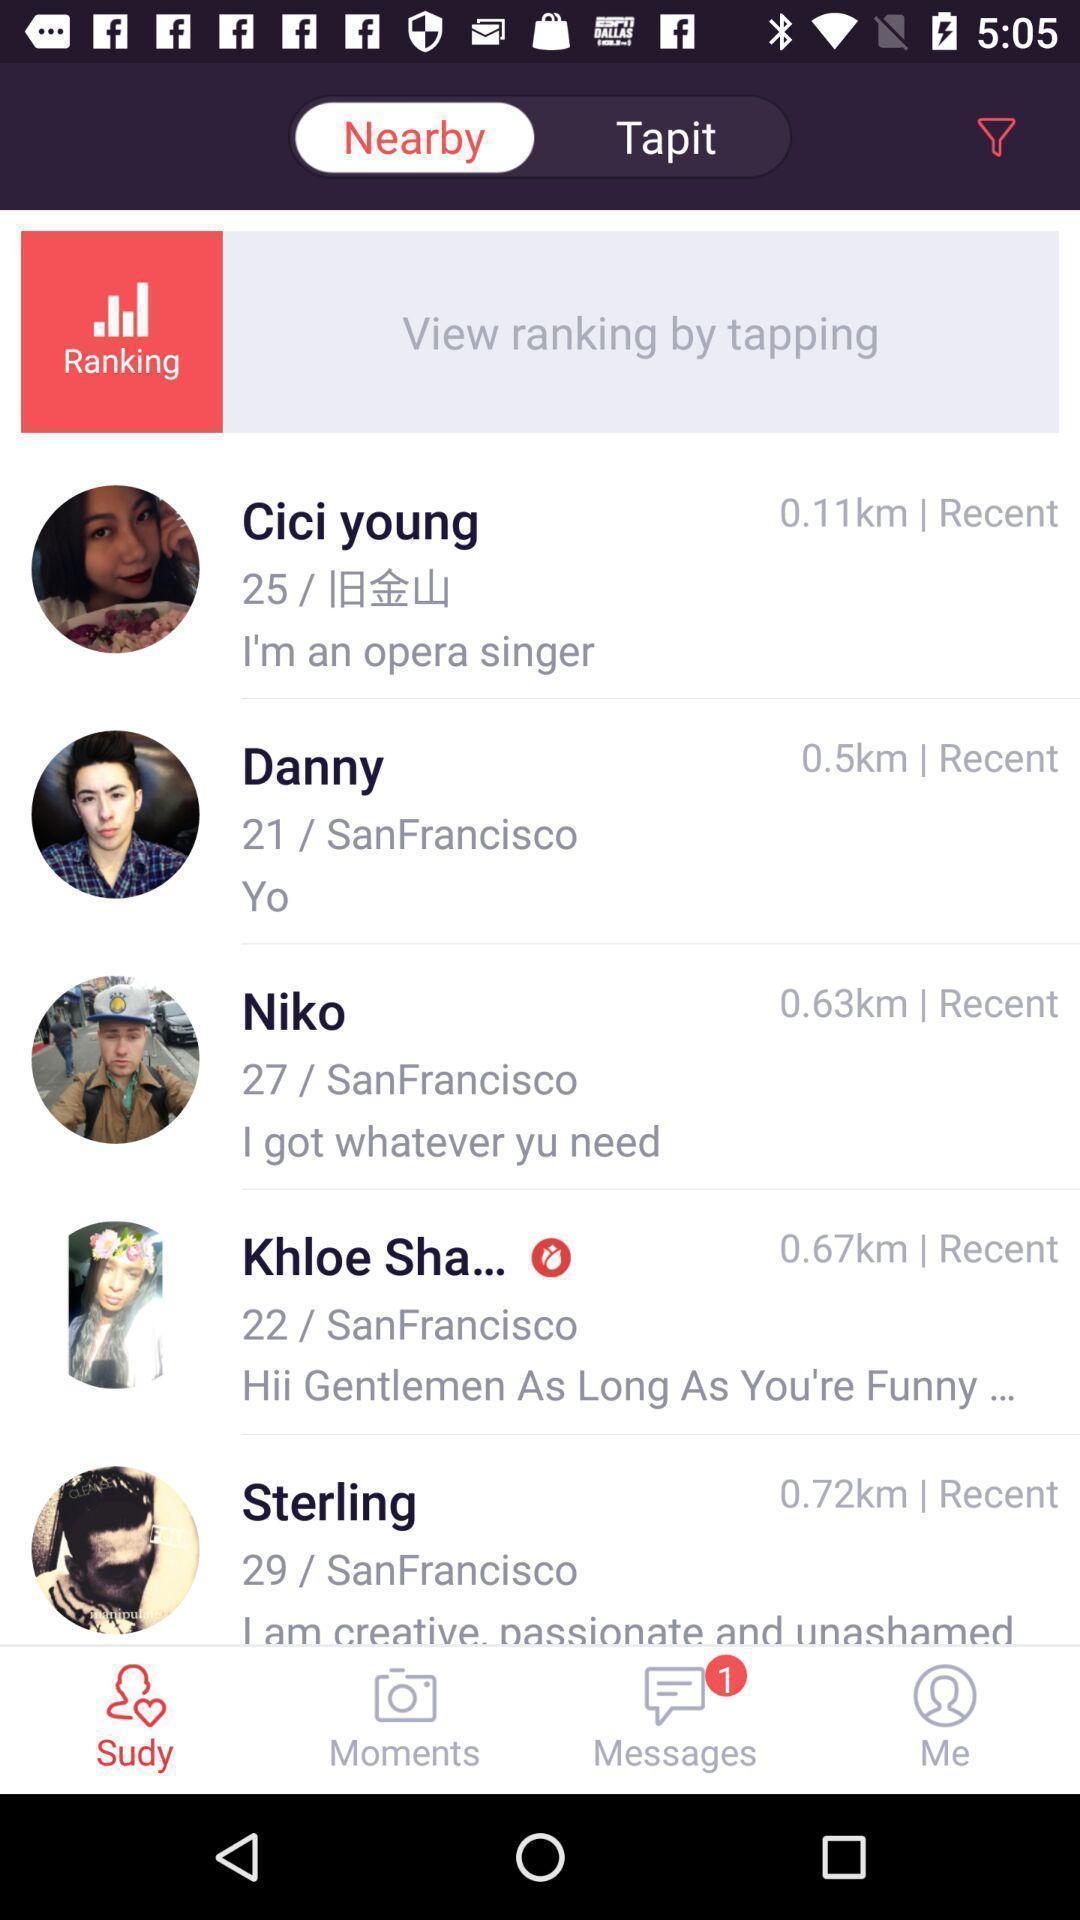Tell me what you see in this picture. Screen displaying multiple users profile information. 